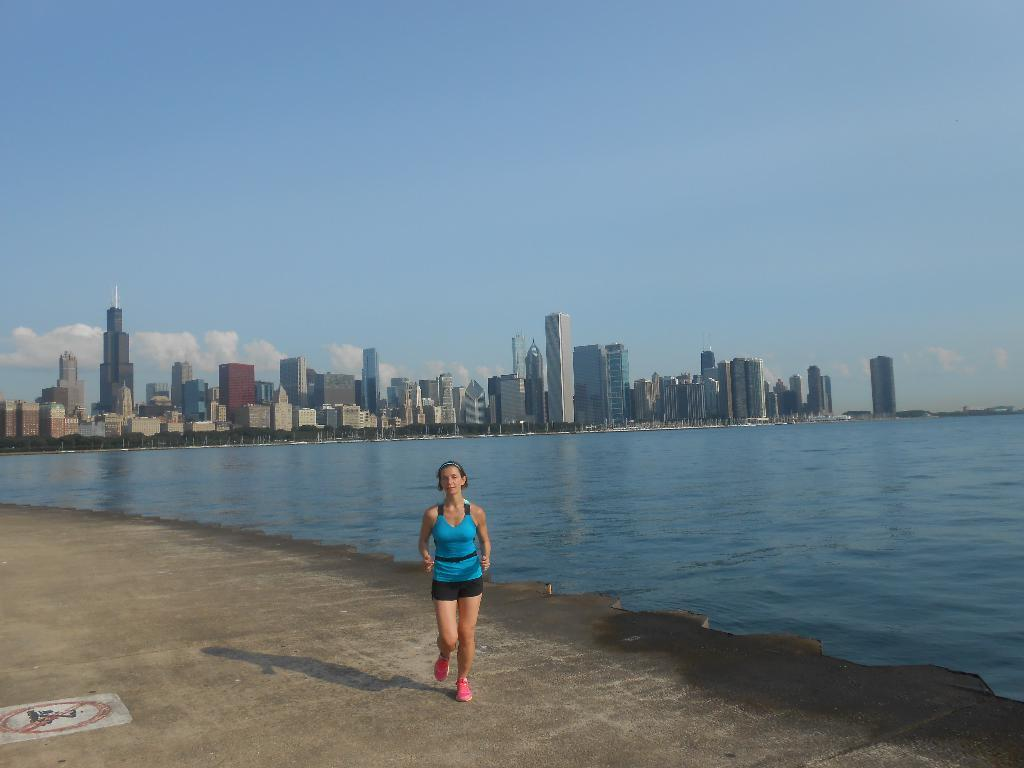What is the woman in the image doing? The woman is running in the image. What can be seen in the background of the image? The sky, clouds, buildings, towers, trees, and water are visible in the background of the image. What type of tools does the carpenter use in the image? There is no carpenter present in the image, so it is not possible to determine what tools they might use. What role does the manager play in the image? There is no manager present in the image, so it is not possible to determine their role. 